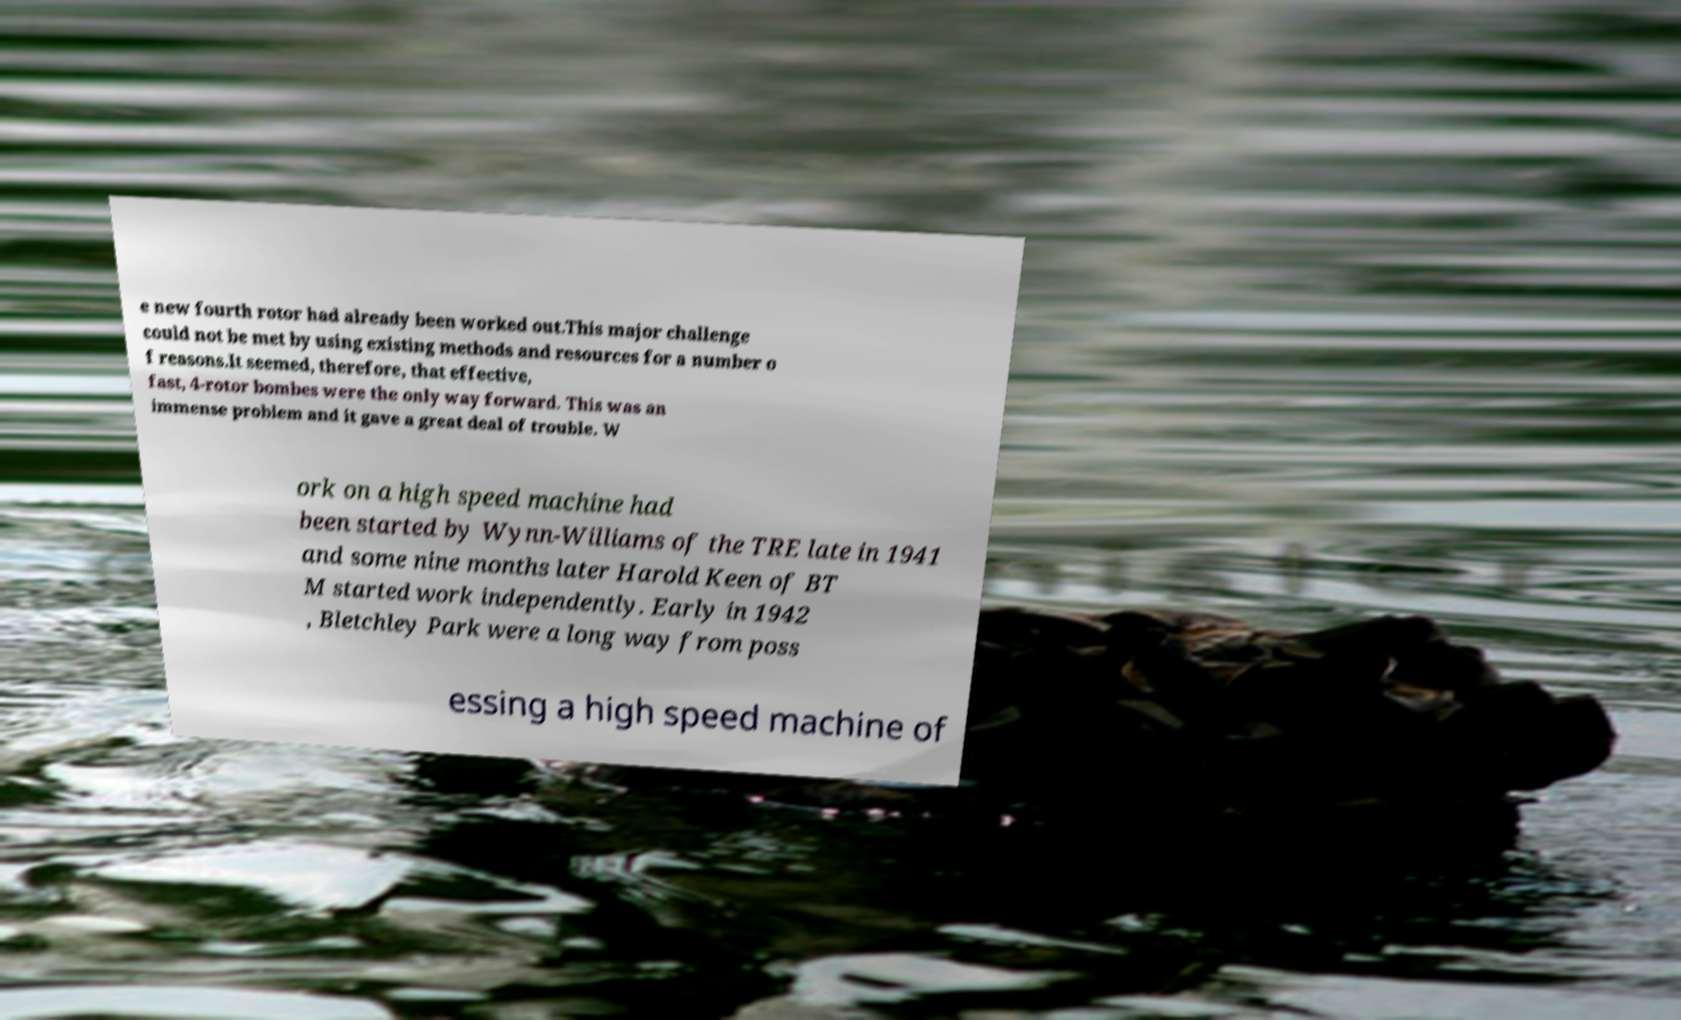Can you read and provide the text displayed in the image?This photo seems to have some interesting text. Can you extract and type it out for me? e new fourth rotor had already been worked out.This major challenge could not be met by using existing methods and resources for a number o f reasons.It seemed, therefore, that effective, fast, 4-rotor bombes were the only way forward. This was an immense problem and it gave a great deal of trouble. W ork on a high speed machine had been started by Wynn-Williams of the TRE late in 1941 and some nine months later Harold Keen of BT M started work independently. Early in 1942 , Bletchley Park were a long way from poss essing a high speed machine of 